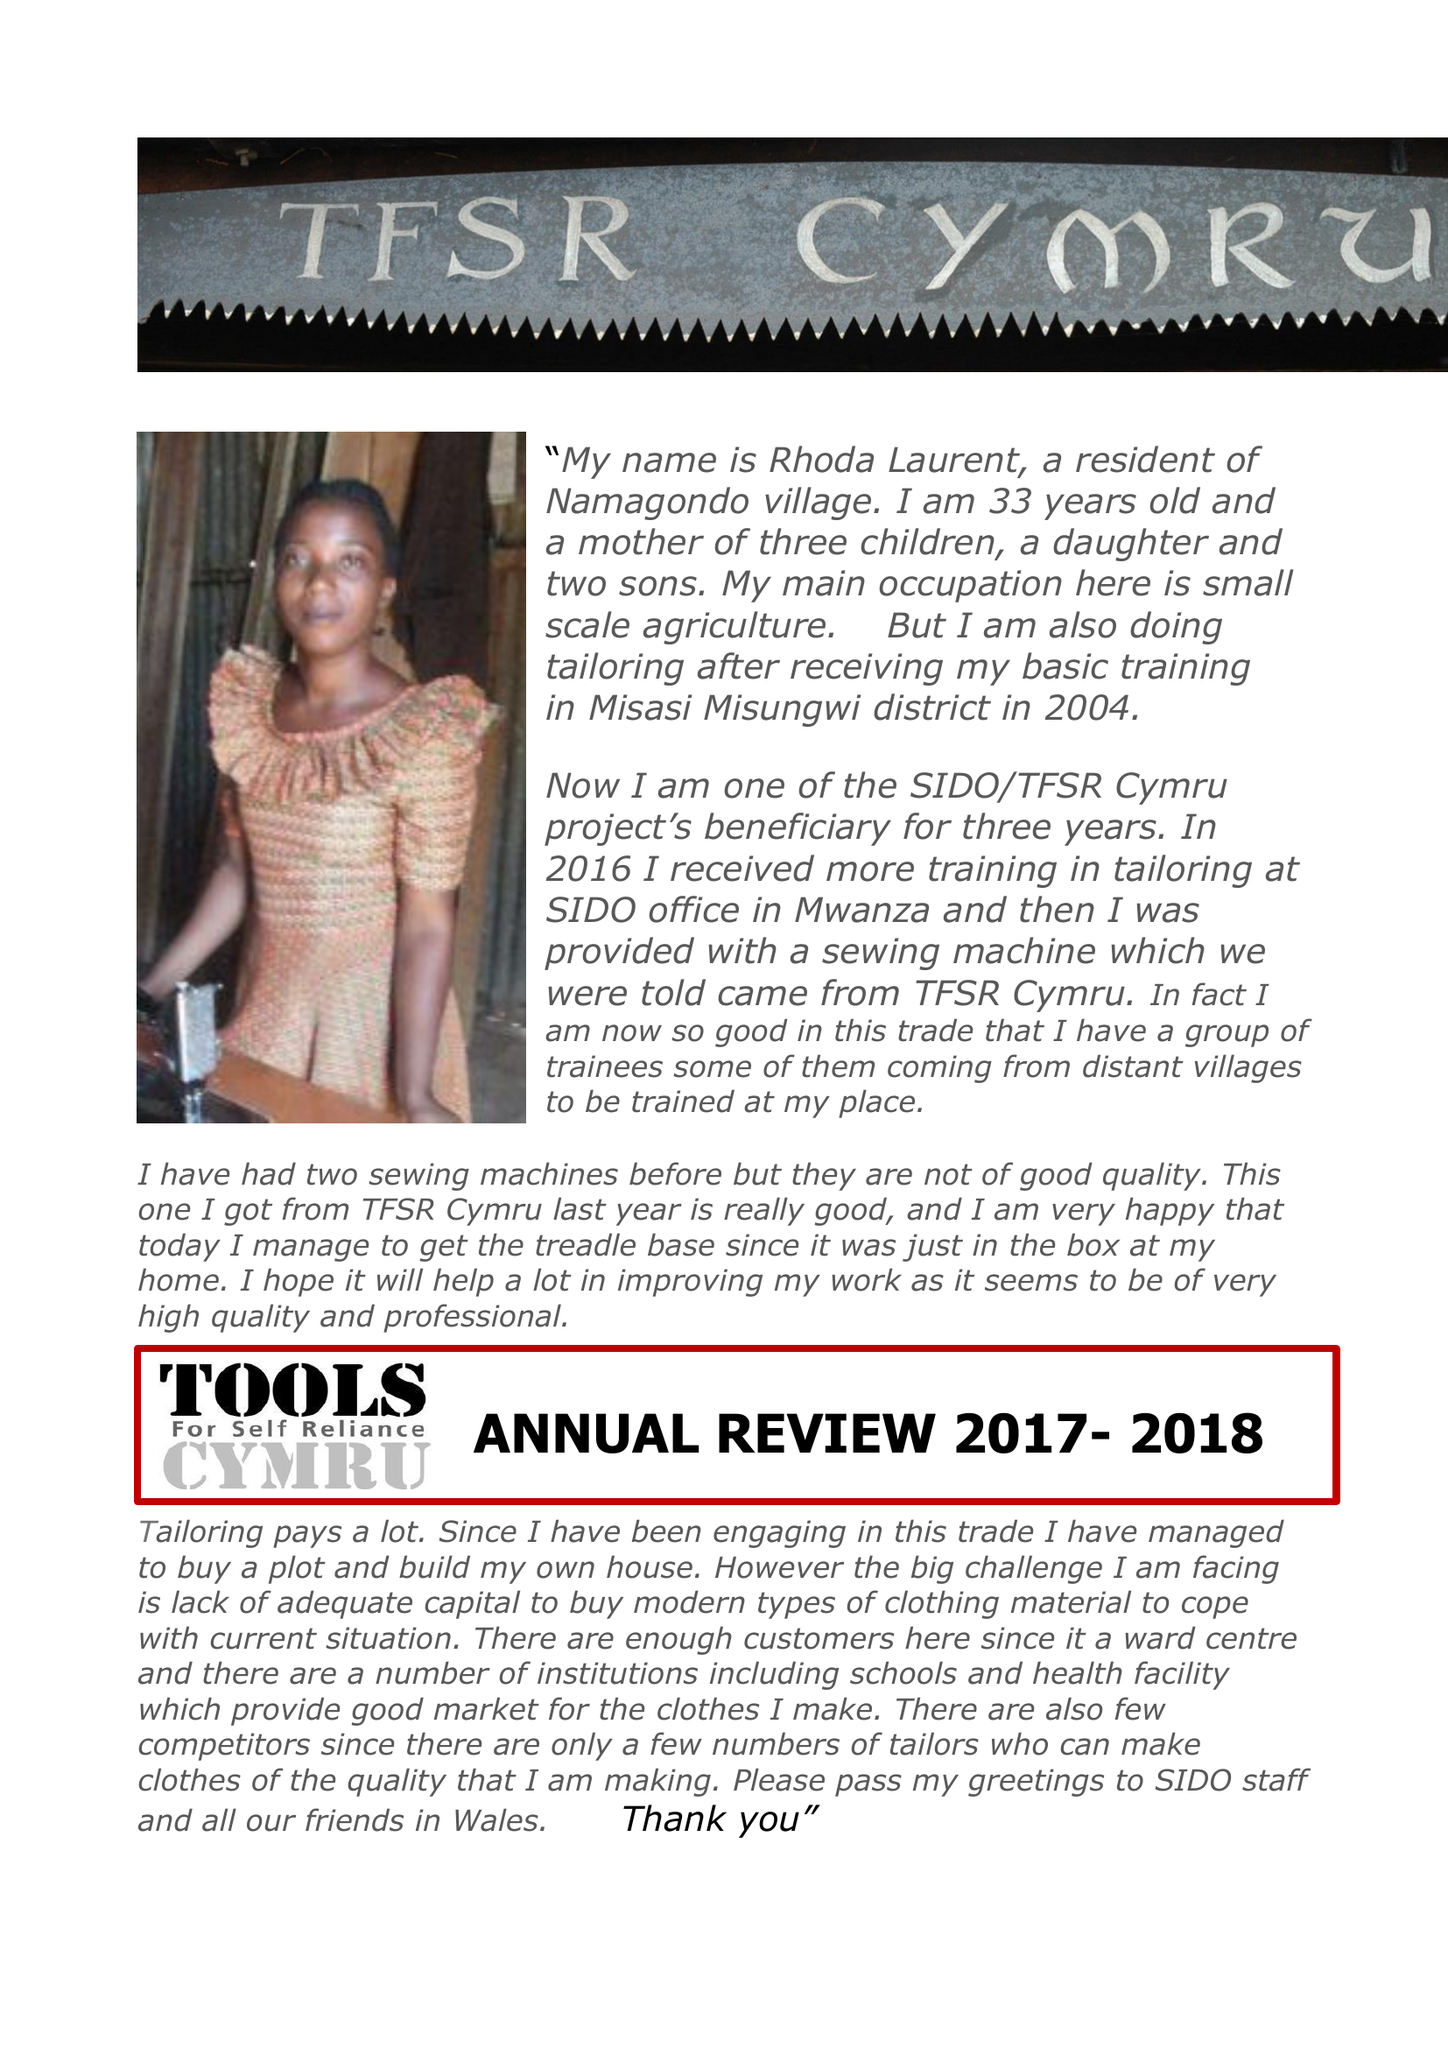What is the value for the address__postcode?
Answer the question using a single word or phrase. NP8 1BZ 